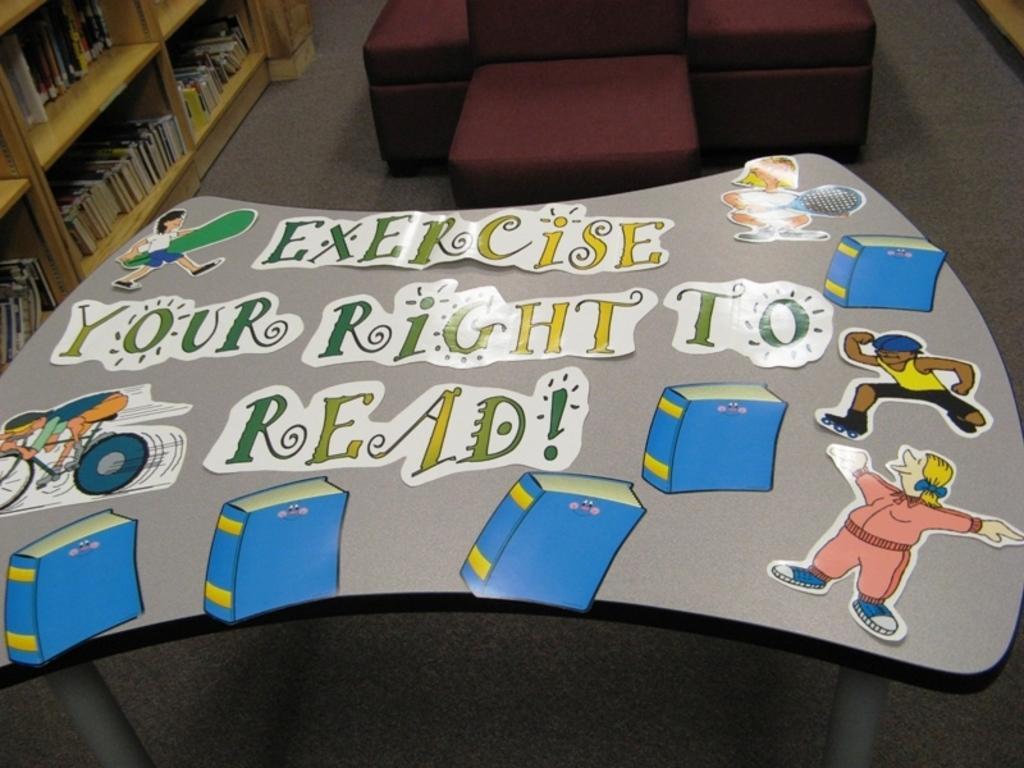Describe this image in one or two sentences. In this picture there is a poster placed on the table which is named 'Exercise your right to read ', in the background we observe a unoccupied sofa and to the left there is an shelf filled with books. 